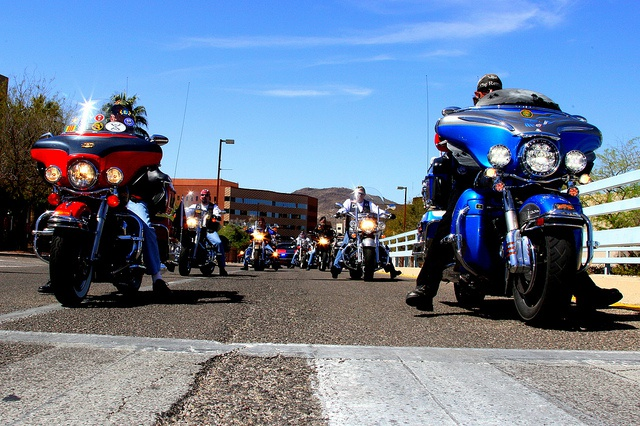Describe the objects in this image and their specific colors. I can see motorcycle in lightblue, black, navy, gray, and blue tones, motorcycle in lightblue, black, maroon, navy, and red tones, people in lightblue, black, gray, darkgray, and maroon tones, motorcycle in lightblue, black, gray, white, and darkgray tones, and people in lightblue, black, navy, and gray tones in this image. 